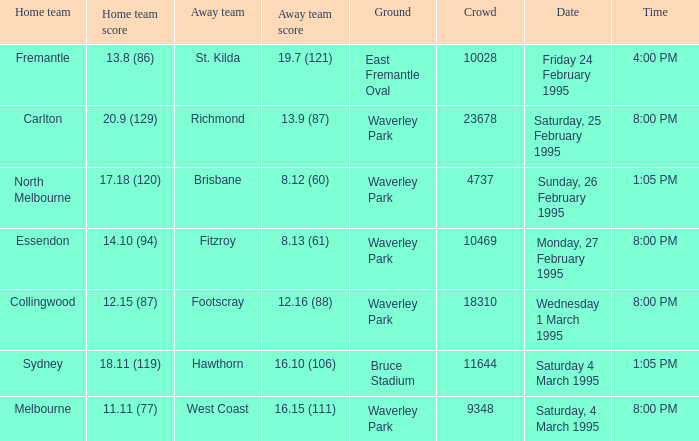Name the total number of grounds for essendon 1.0. 